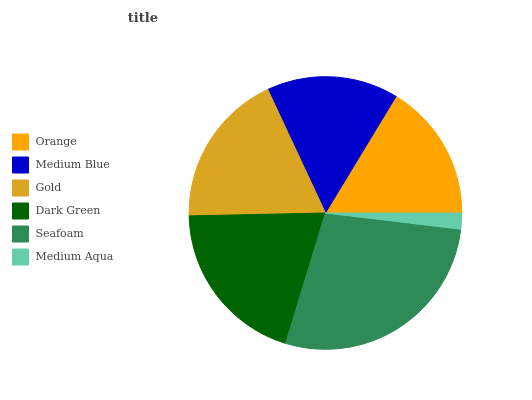Is Medium Aqua the minimum?
Answer yes or no. Yes. Is Seafoam the maximum?
Answer yes or no. Yes. Is Medium Blue the minimum?
Answer yes or no. No. Is Medium Blue the maximum?
Answer yes or no. No. Is Orange greater than Medium Blue?
Answer yes or no. Yes. Is Medium Blue less than Orange?
Answer yes or no. Yes. Is Medium Blue greater than Orange?
Answer yes or no. No. Is Orange less than Medium Blue?
Answer yes or no. No. Is Gold the high median?
Answer yes or no. Yes. Is Orange the low median?
Answer yes or no. Yes. Is Seafoam the high median?
Answer yes or no. No. Is Medium Blue the low median?
Answer yes or no. No. 